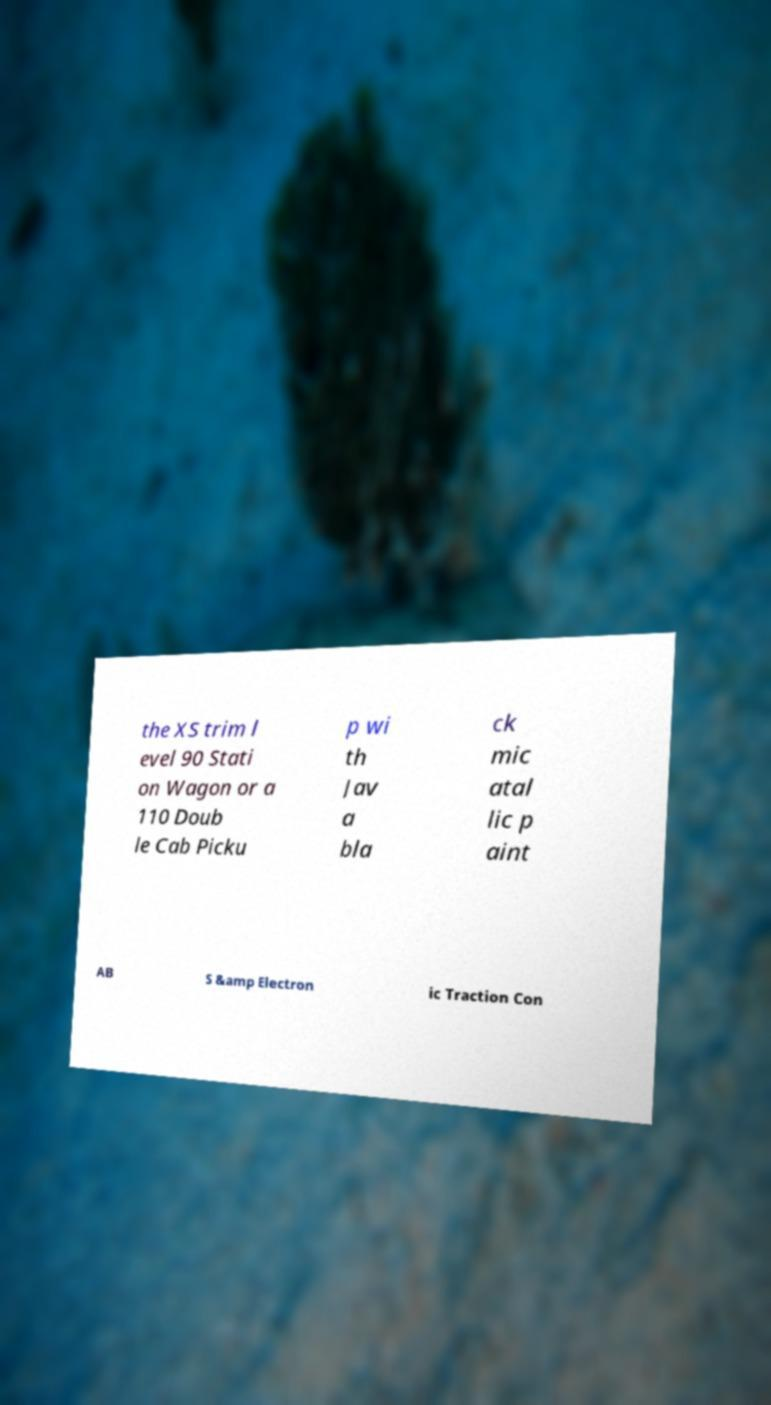Can you accurately transcribe the text from the provided image for me? the XS trim l evel 90 Stati on Wagon or a 110 Doub le Cab Picku p wi th Jav a bla ck mic atal lic p aint AB S &amp Electron ic Traction Con 